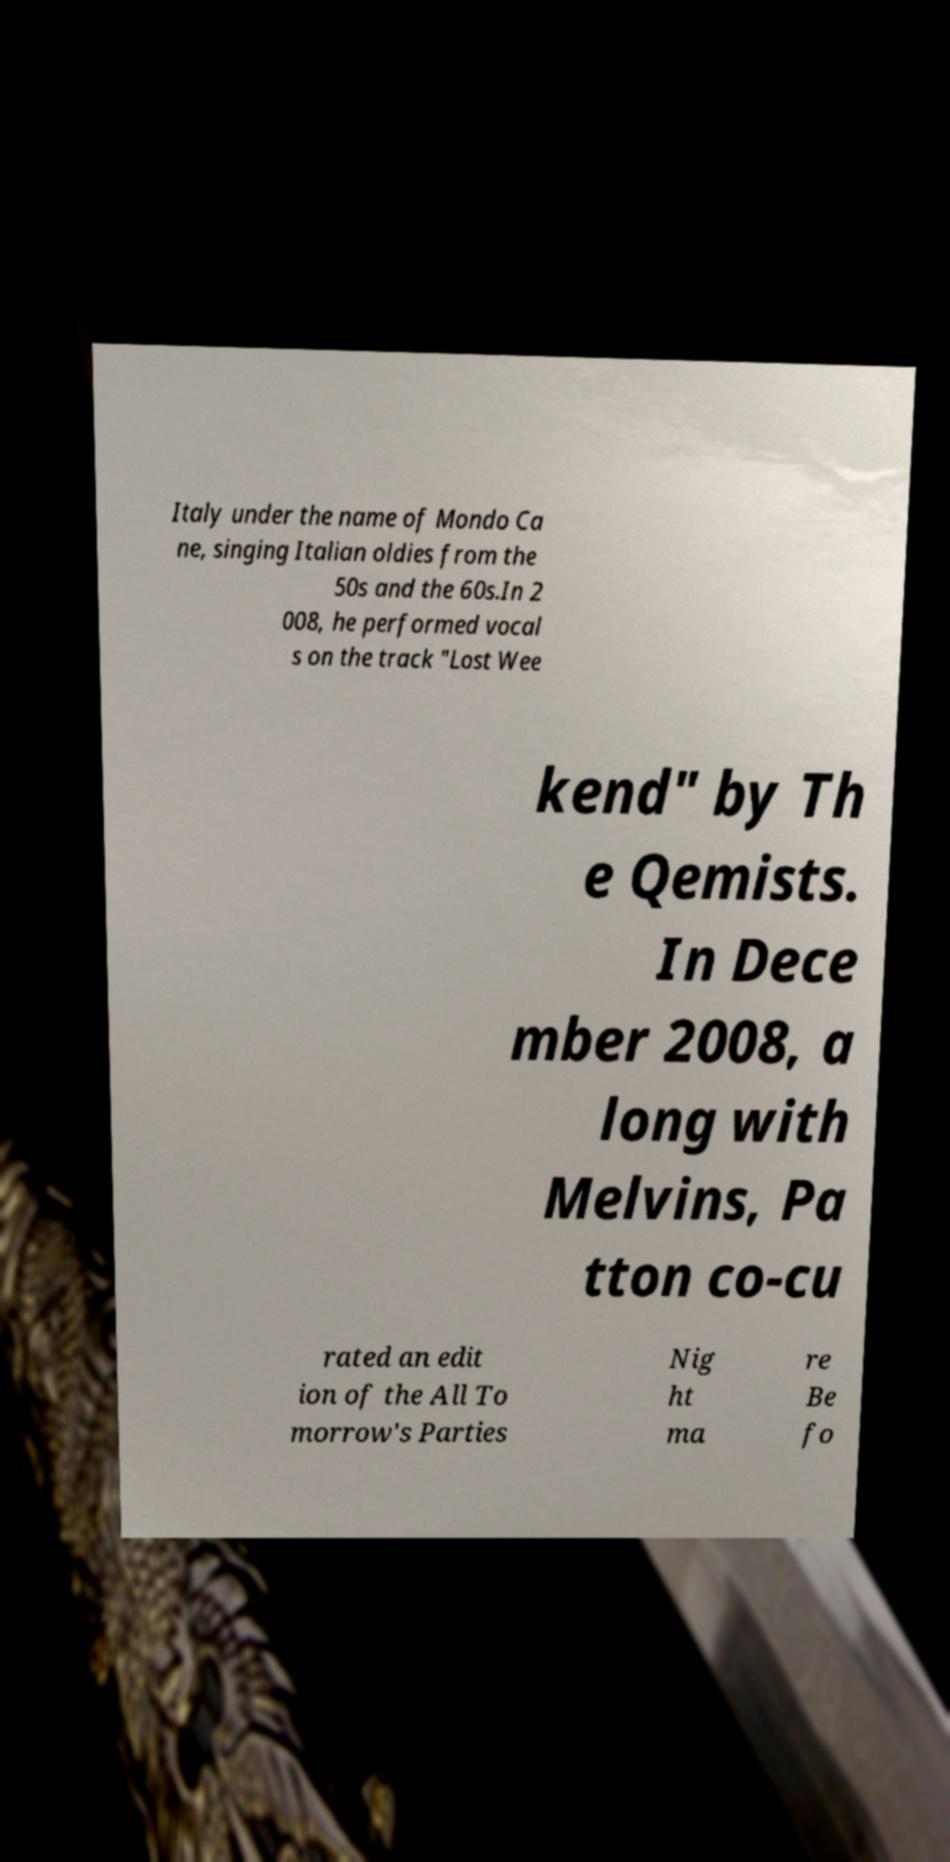Please read and relay the text visible in this image. What does it say? Italy under the name of Mondo Ca ne, singing Italian oldies from the 50s and the 60s.In 2 008, he performed vocal s on the track "Lost Wee kend" by Th e Qemists. In Dece mber 2008, a long with Melvins, Pa tton co-cu rated an edit ion of the All To morrow's Parties Nig ht ma re Be fo 